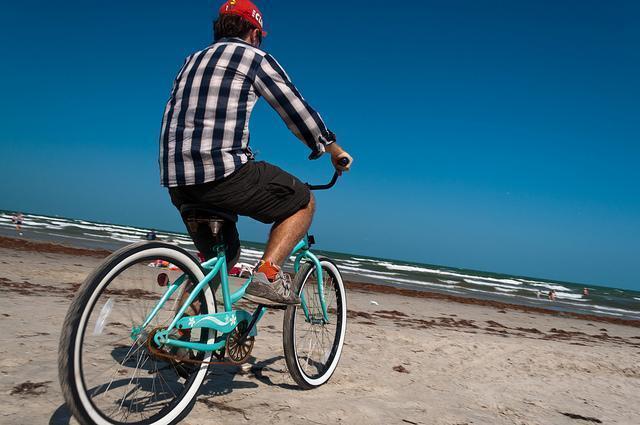What will happen to this mans feet if he doesn't stop?
Indicate the correct response and explain using: 'Answer: answer
Rationale: rationale.'
Options: Nothing, get wet, twist, burn. Answer: get wet.
Rationale: He is headed toward the water 